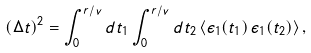Convert formula to latex. <formula><loc_0><loc_0><loc_500><loc_500>( \Delta t ) ^ { 2 } = \int _ { 0 } ^ { r / v } d t _ { 1 } \int _ { 0 } ^ { r / v } d t _ { 2 } \, \langle \epsilon _ { 1 } ( t _ { 1 } ) \, \epsilon _ { 1 } ( t _ { 2 } ) \rangle \, ,</formula> 